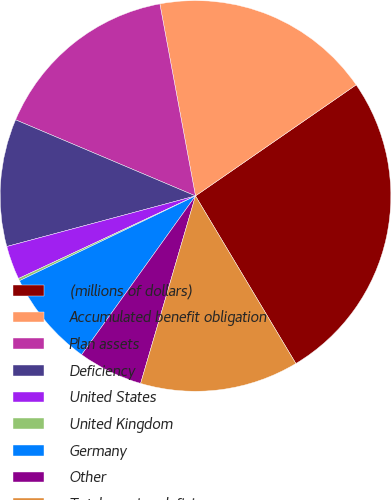<chart> <loc_0><loc_0><loc_500><loc_500><pie_chart><fcel>(millions of dollars)<fcel>Accumulated benefit obligation<fcel>Plan assets<fcel>Deficiency<fcel>United States<fcel>United Kingdom<fcel>Germany<fcel>Other<fcel>Total pension deficiency<nl><fcel>26.04%<fcel>18.29%<fcel>15.71%<fcel>10.54%<fcel>2.78%<fcel>0.2%<fcel>7.95%<fcel>5.37%<fcel>13.12%<nl></chart> 